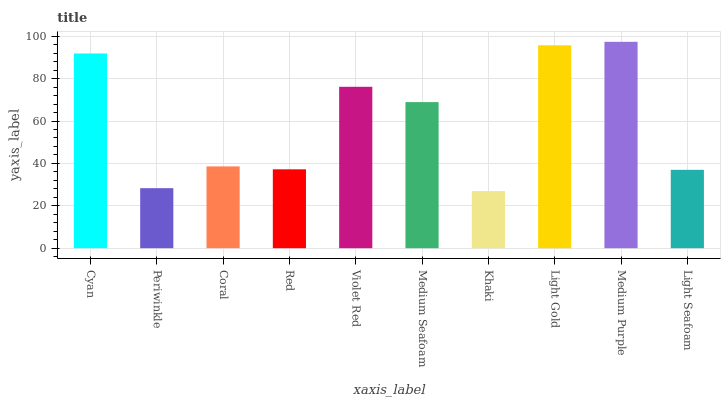Is Periwinkle the minimum?
Answer yes or no. No. Is Periwinkle the maximum?
Answer yes or no. No. Is Cyan greater than Periwinkle?
Answer yes or no. Yes. Is Periwinkle less than Cyan?
Answer yes or no. Yes. Is Periwinkle greater than Cyan?
Answer yes or no. No. Is Cyan less than Periwinkle?
Answer yes or no. No. Is Medium Seafoam the high median?
Answer yes or no. Yes. Is Coral the low median?
Answer yes or no. Yes. Is Medium Purple the high median?
Answer yes or no. No. Is Light Seafoam the low median?
Answer yes or no. No. 